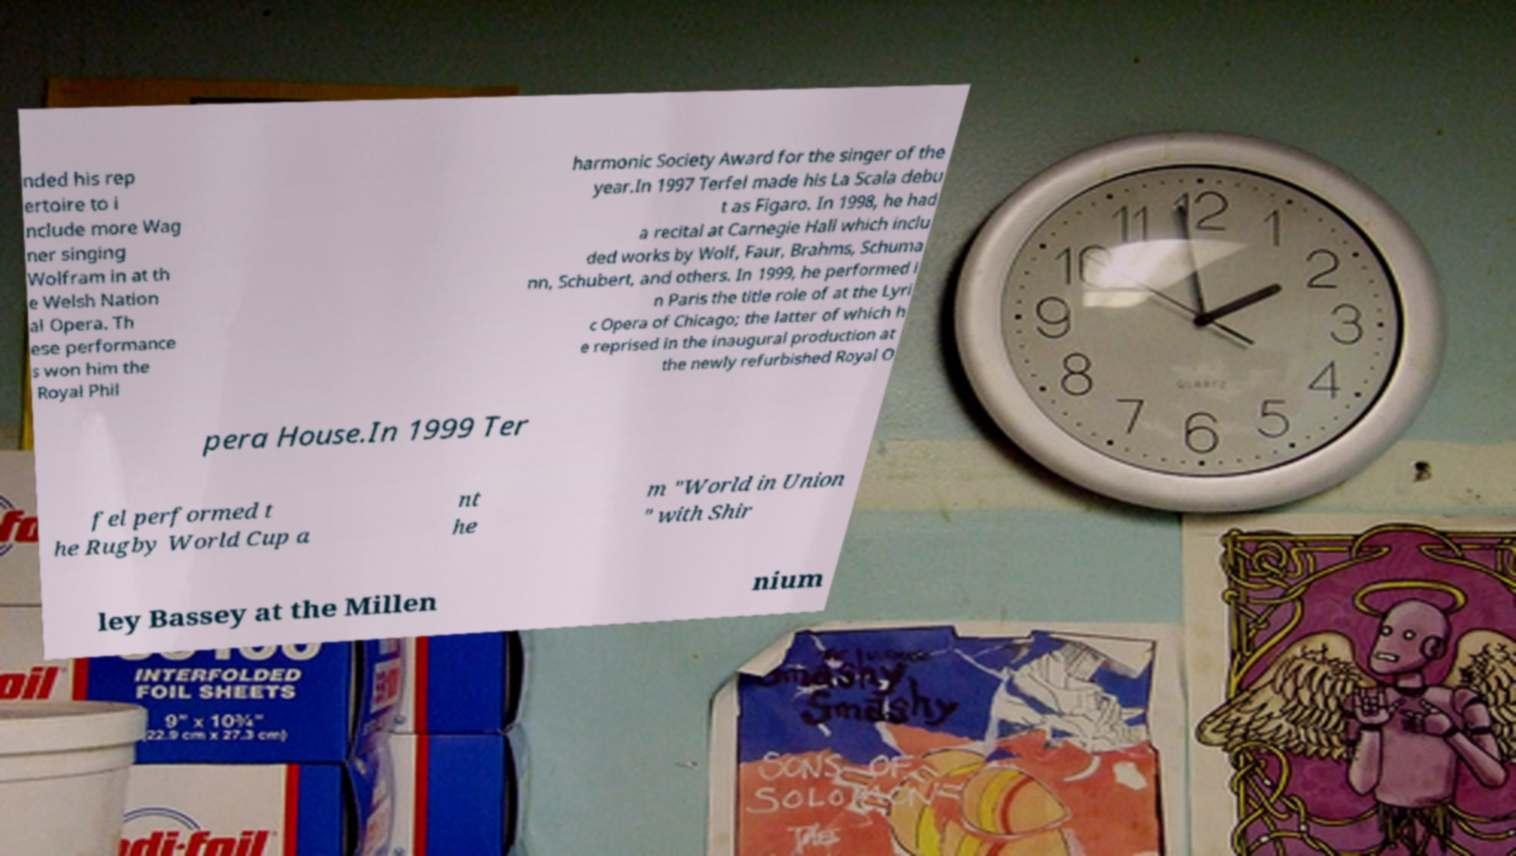Could you extract and type out the text from this image? nded his rep ertoire to i nclude more Wag ner singing Wolfram in at th e Welsh Nation al Opera. Th ese performance s won him the Royal Phil harmonic Society Award for the singer of the year.In 1997 Terfel made his La Scala debu t as Figaro. In 1998, he had a recital at Carnegie Hall which inclu ded works by Wolf, Faur, Brahms, Schuma nn, Schubert, and others. In 1999, he performed i n Paris the title role of at the Lyri c Opera of Chicago; the latter of which h e reprised in the inaugural production at the newly refurbished Royal O pera House.In 1999 Ter fel performed t he Rugby World Cup a nt he m "World in Union " with Shir ley Bassey at the Millen nium 